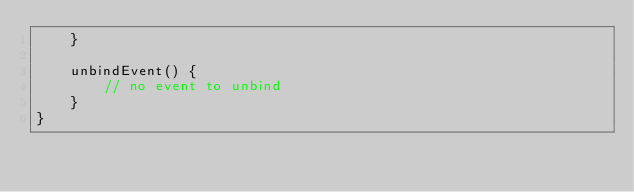<code> <loc_0><loc_0><loc_500><loc_500><_TypeScript_>    }
    
    unbindEvent() {
        // no event to unbind
    }
}
</code> 